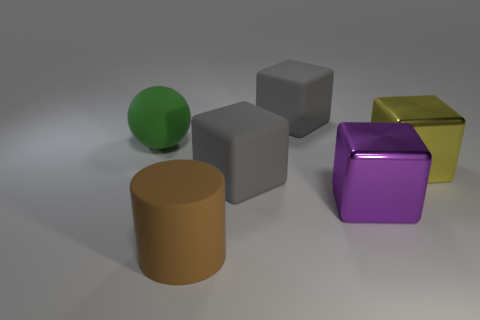Add 1 green cubes. How many objects exist? 7 Subtract all spheres. How many objects are left? 5 Subtract 0 red blocks. How many objects are left? 6 Subtract all matte cubes. Subtract all brown rubber cylinders. How many objects are left? 3 Add 6 large gray rubber objects. How many large gray rubber objects are left? 8 Add 5 small gray matte objects. How many small gray matte objects exist? 5 